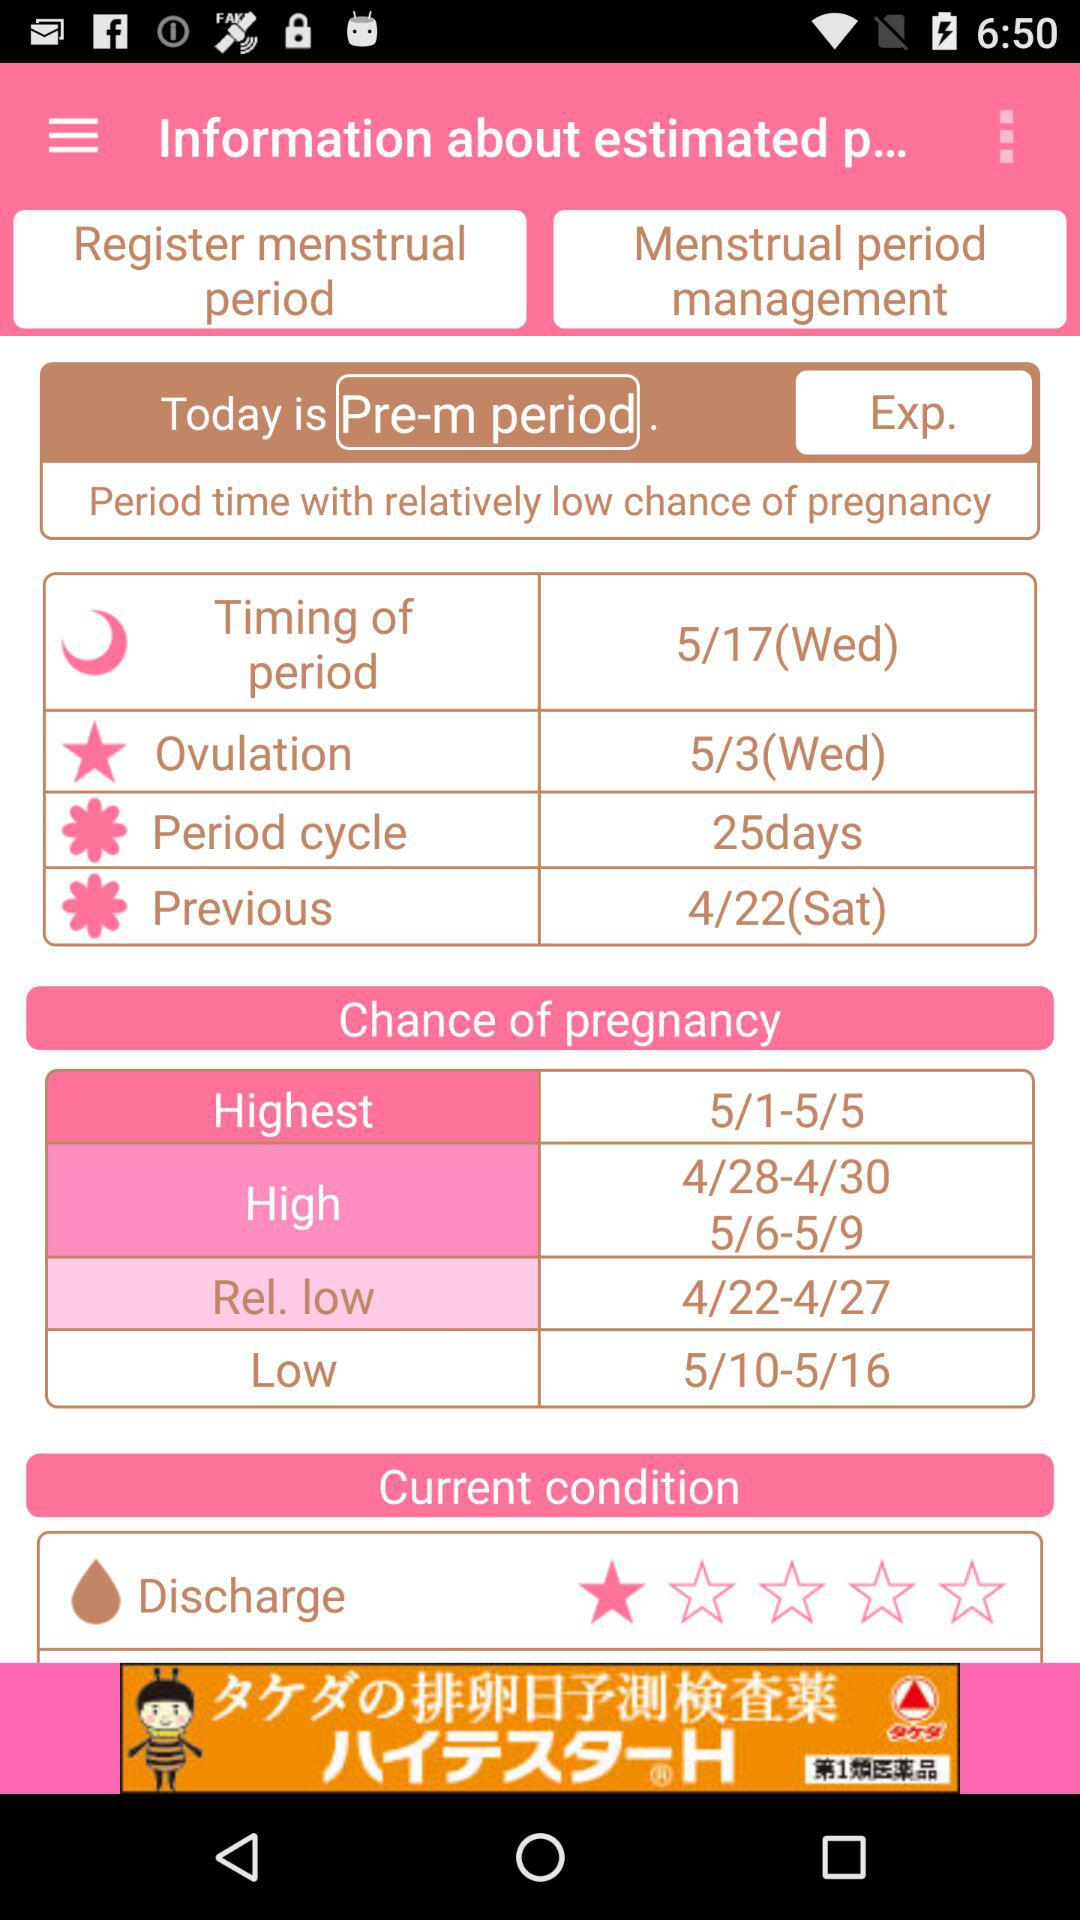What is the star rating of discharge in current condition? The rating is 1 star. 